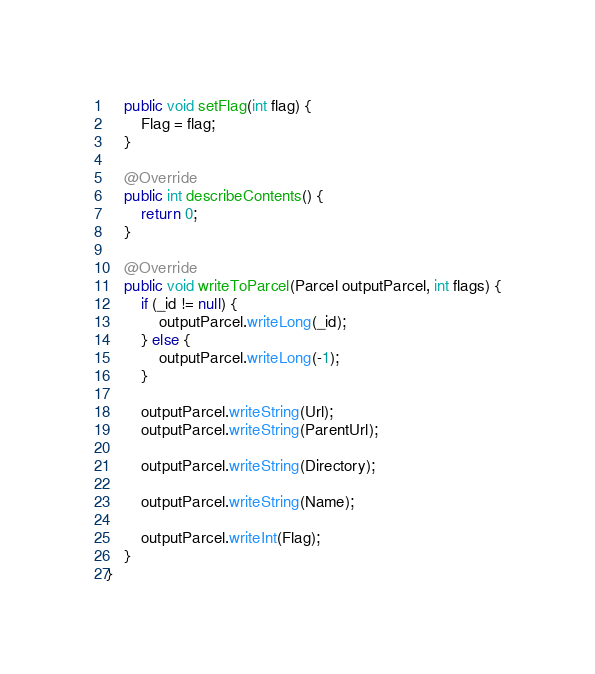Convert code to text. <code><loc_0><loc_0><loc_500><loc_500><_Java_>
    public void setFlag(int flag) {
        Flag = flag;
    }

    @Override
    public int describeContents() {
        return 0;
    }

    @Override
    public void writeToParcel(Parcel outputParcel, int flags) {
        if (_id != null) {
            outputParcel.writeLong(_id);
        } else {
            outputParcel.writeLong(-1);
        }

        outputParcel.writeString(Url);
        outputParcel.writeString(ParentUrl);

        outputParcel.writeString(Directory);

        outputParcel.writeString(Name);

        outputParcel.writeInt(Flag);
    }
}
</code> 